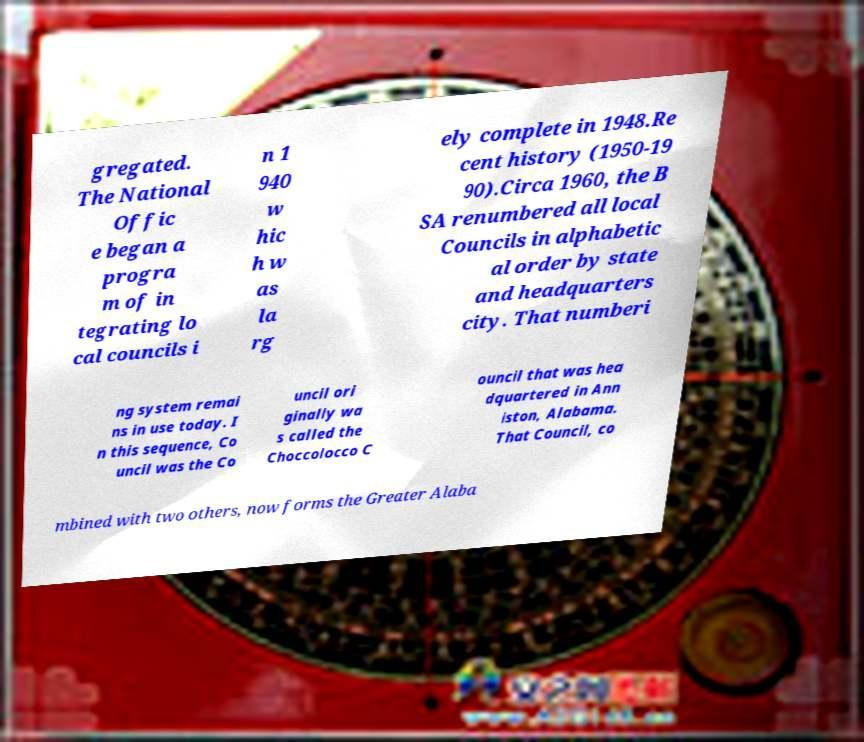There's text embedded in this image that I need extracted. Can you transcribe it verbatim? gregated. The National Offic e began a progra m of in tegrating lo cal councils i n 1 940 w hic h w as la rg ely complete in 1948.Re cent history (1950-19 90).Circa 1960, the B SA renumbered all local Councils in alphabetic al order by state and headquarters city. That numberi ng system remai ns in use today. I n this sequence, Co uncil was the Co uncil ori ginally wa s called the Choccolocco C ouncil that was hea dquartered in Ann iston, Alabama. That Council, co mbined with two others, now forms the Greater Alaba 